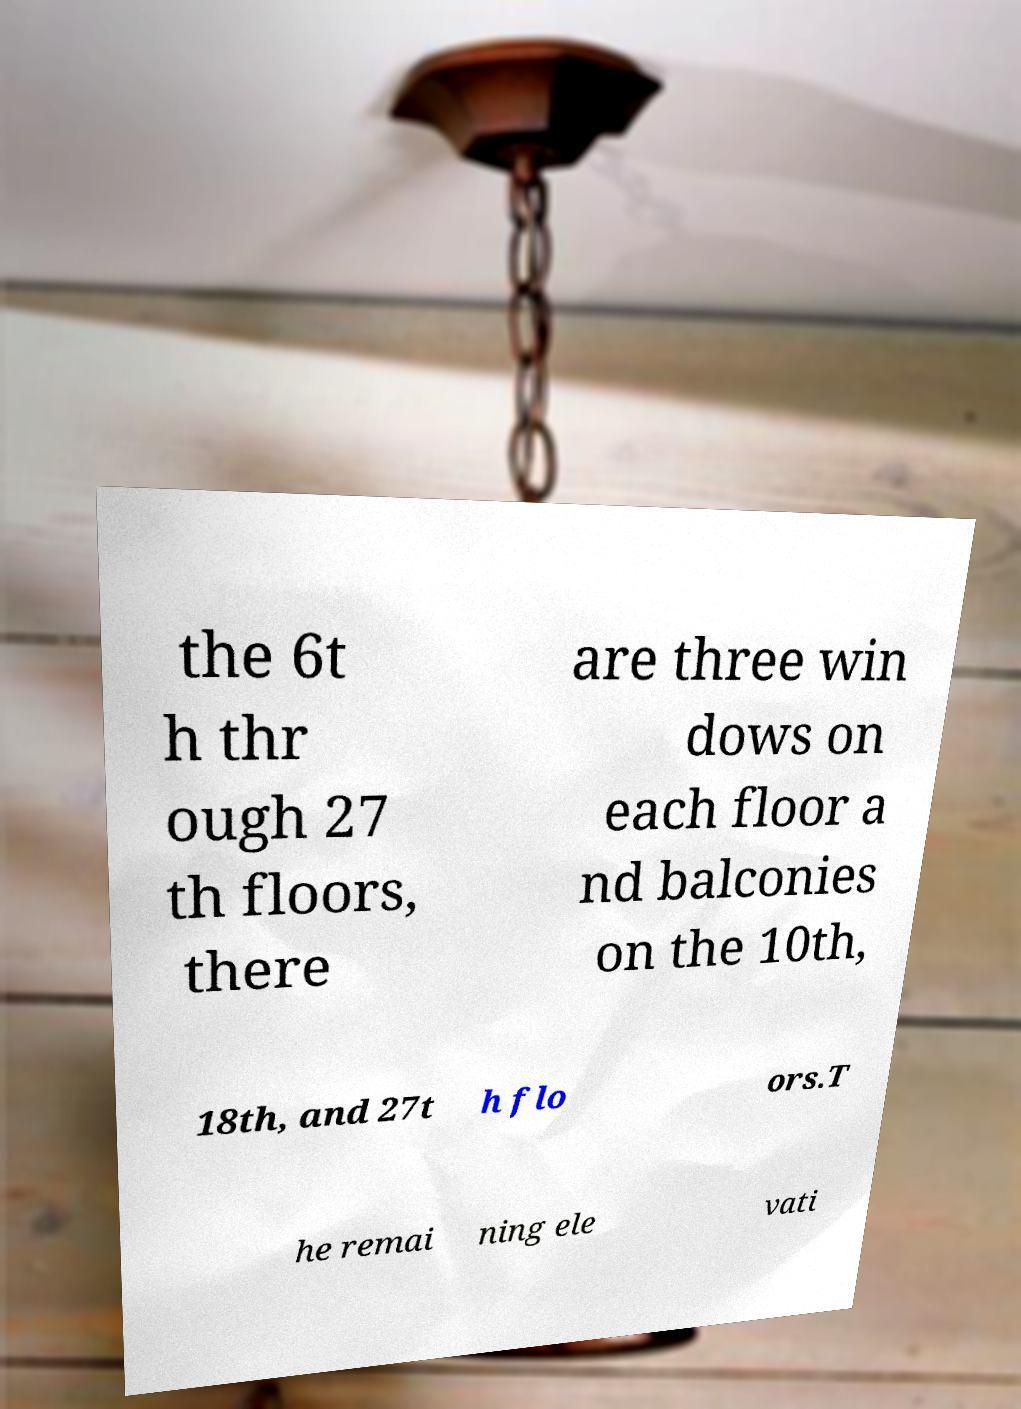For documentation purposes, I need the text within this image transcribed. Could you provide that? the 6t h thr ough 27 th floors, there are three win dows on each floor a nd balconies on the 10th, 18th, and 27t h flo ors.T he remai ning ele vati 